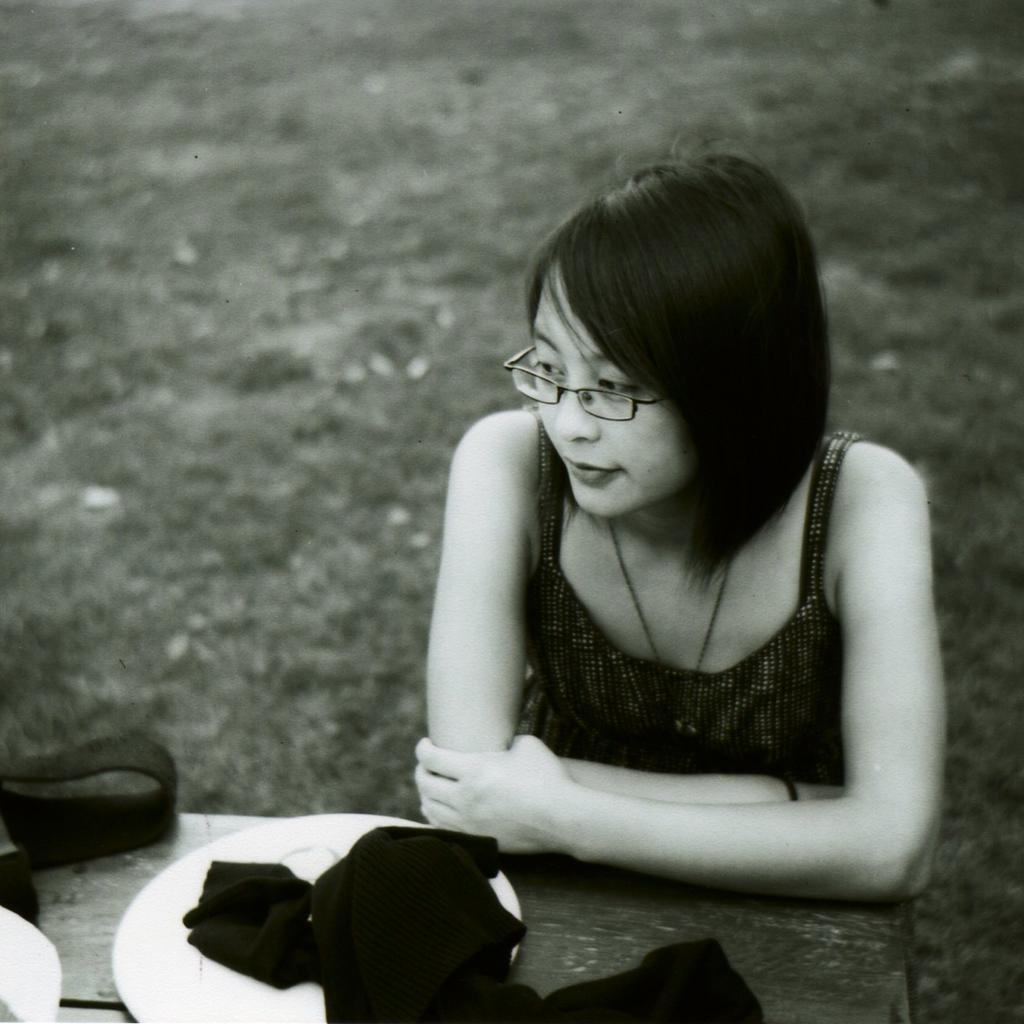What is present in the image? There is a person in the image. Can you describe the person's appearance? The person is wearing clothes and spectacles. What is located at the bottom of the image? There is a table at the bottom of the image. What items are on the table? The table contains a plate and a cloth. How would you describe the background of the image? The background of the image is blurred. How does the person's digestion process appear in the image? There is no indication of the person's digestion process in the image. Is the person wearing a mask in the image? No, the person is wearing spectacles, not a mask. 